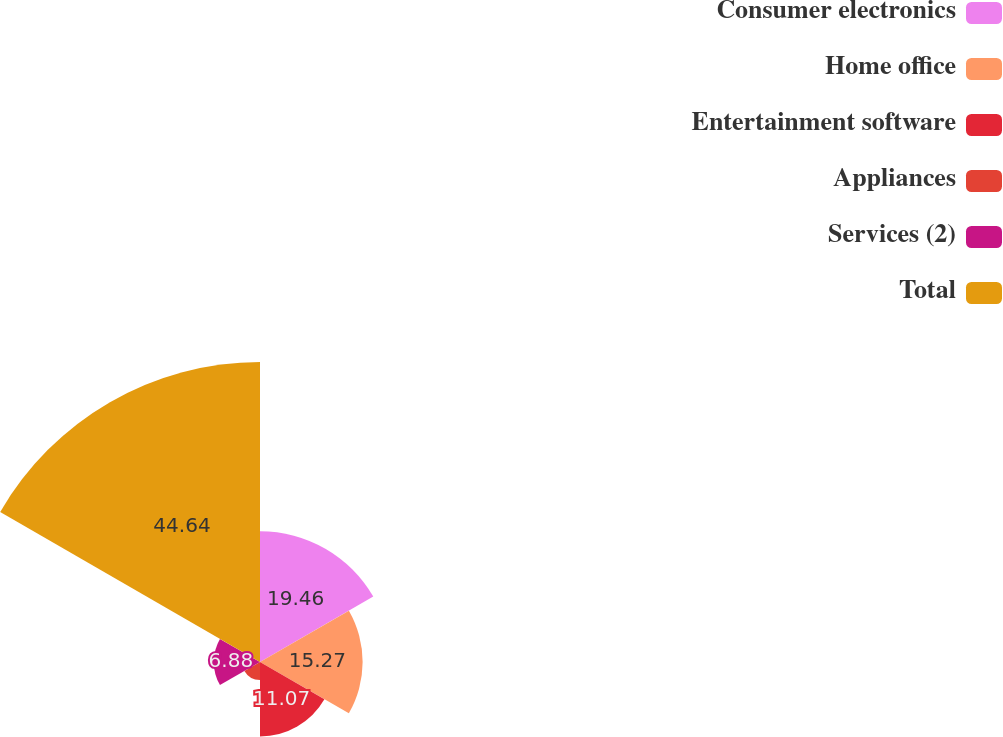Convert chart to OTSL. <chart><loc_0><loc_0><loc_500><loc_500><pie_chart><fcel>Consumer electronics<fcel>Home office<fcel>Entertainment software<fcel>Appliances<fcel>Services (2)<fcel>Total<nl><fcel>19.46%<fcel>15.27%<fcel>11.07%<fcel>2.68%<fcel>6.88%<fcel>44.64%<nl></chart> 